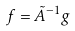Convert formula to latex. <formula><loc_0><loc_0><loc_500><loc_500>f = \tilde { A } ^ { - 1 } g</formula> 